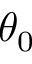Convert formula to latex. <formula><loc_0><loc_0><loc_500><loc_500>\theta _ { 0 }</formula> 